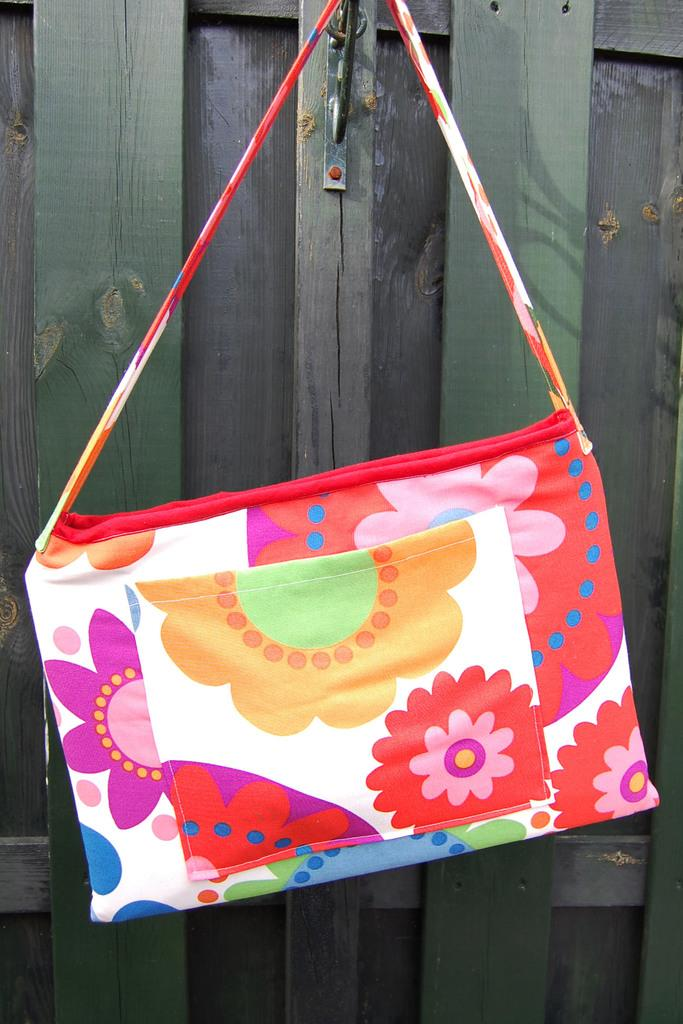What is hanging on the wall in the image? There is a colorful bag hanging on a wall in the image. Can you describe the appearance of the bag? The bag is colorful, but no specific colors are mentioned in the facts. How is the bag attached to the wall? The facts do not specify how the bag is attached to the wall. How many snakes are coiled around the bag in the image? There are no snakes present in the image; it only features a colorful bag hanging on a wall. 